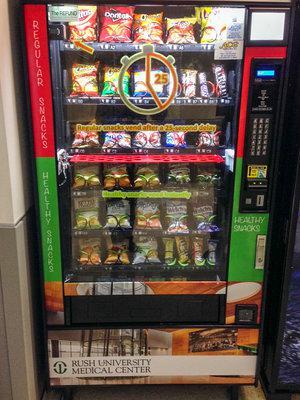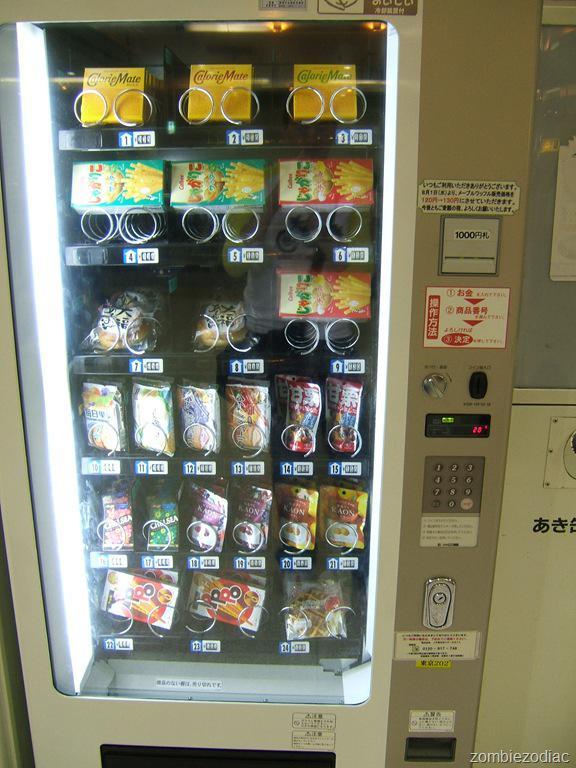The first image is the image on the left, the second image is the image on the right. Given the left and right images, does the statement "The vending machine on the left has green color on its frame." hold true? Answer yes or no. Yes. 